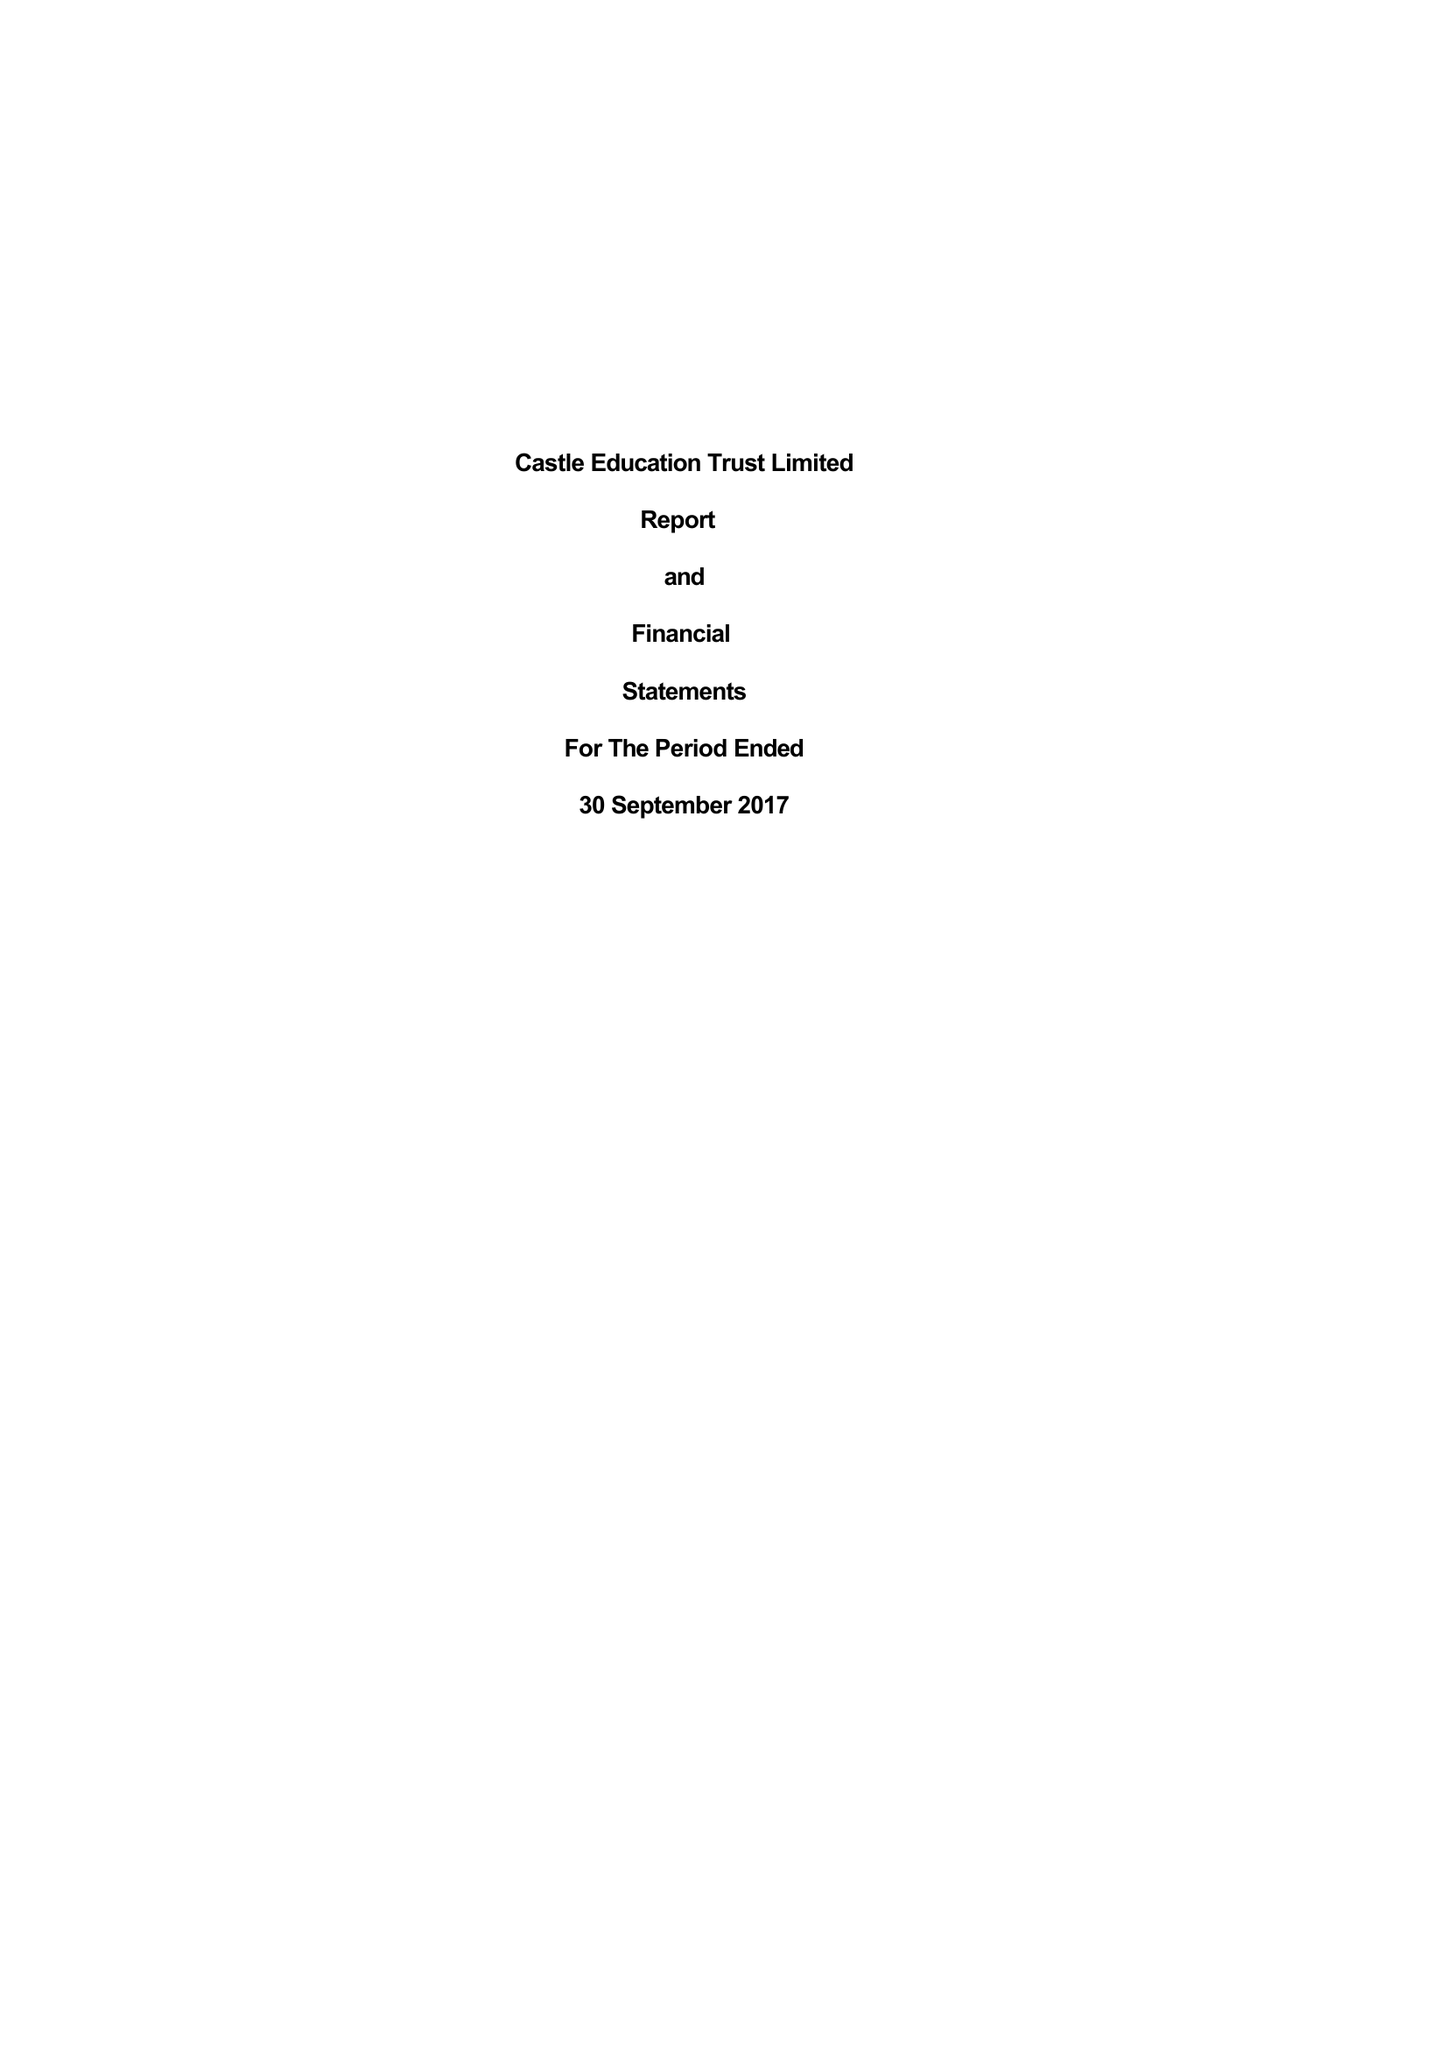What is the value for the address__post_town?
Answer the question using a single word or phrase. LONDON 